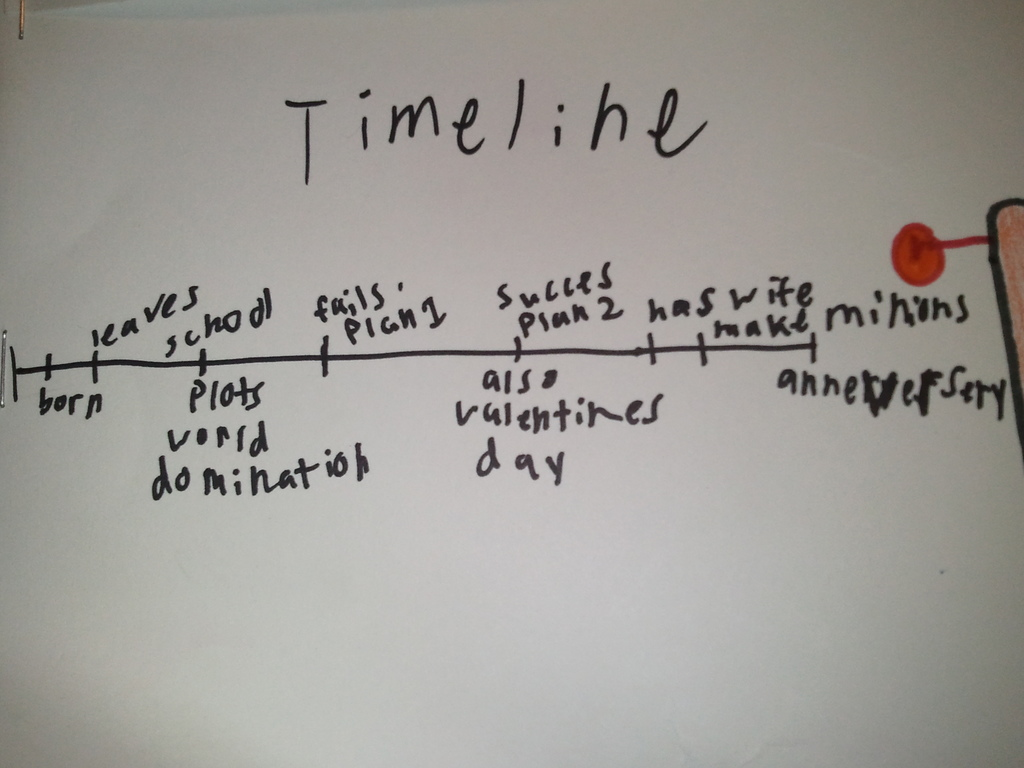Why do you think 'thank minions' is listed on this timeline? The inclusion of 'thank minions' on this hand-drawn timeline injects a sense of humor and appreciation into the life events presented. It whimsically acknowledges the help or support from others—referred to playfully as 'minions'—which is important in any endeavor, whether it be an actual project or a fictional scheme for world domination. This reflects an understanding that success often involves collaboration and the contributions of many, and this entry serves as a lighthearted nod to that fact. 